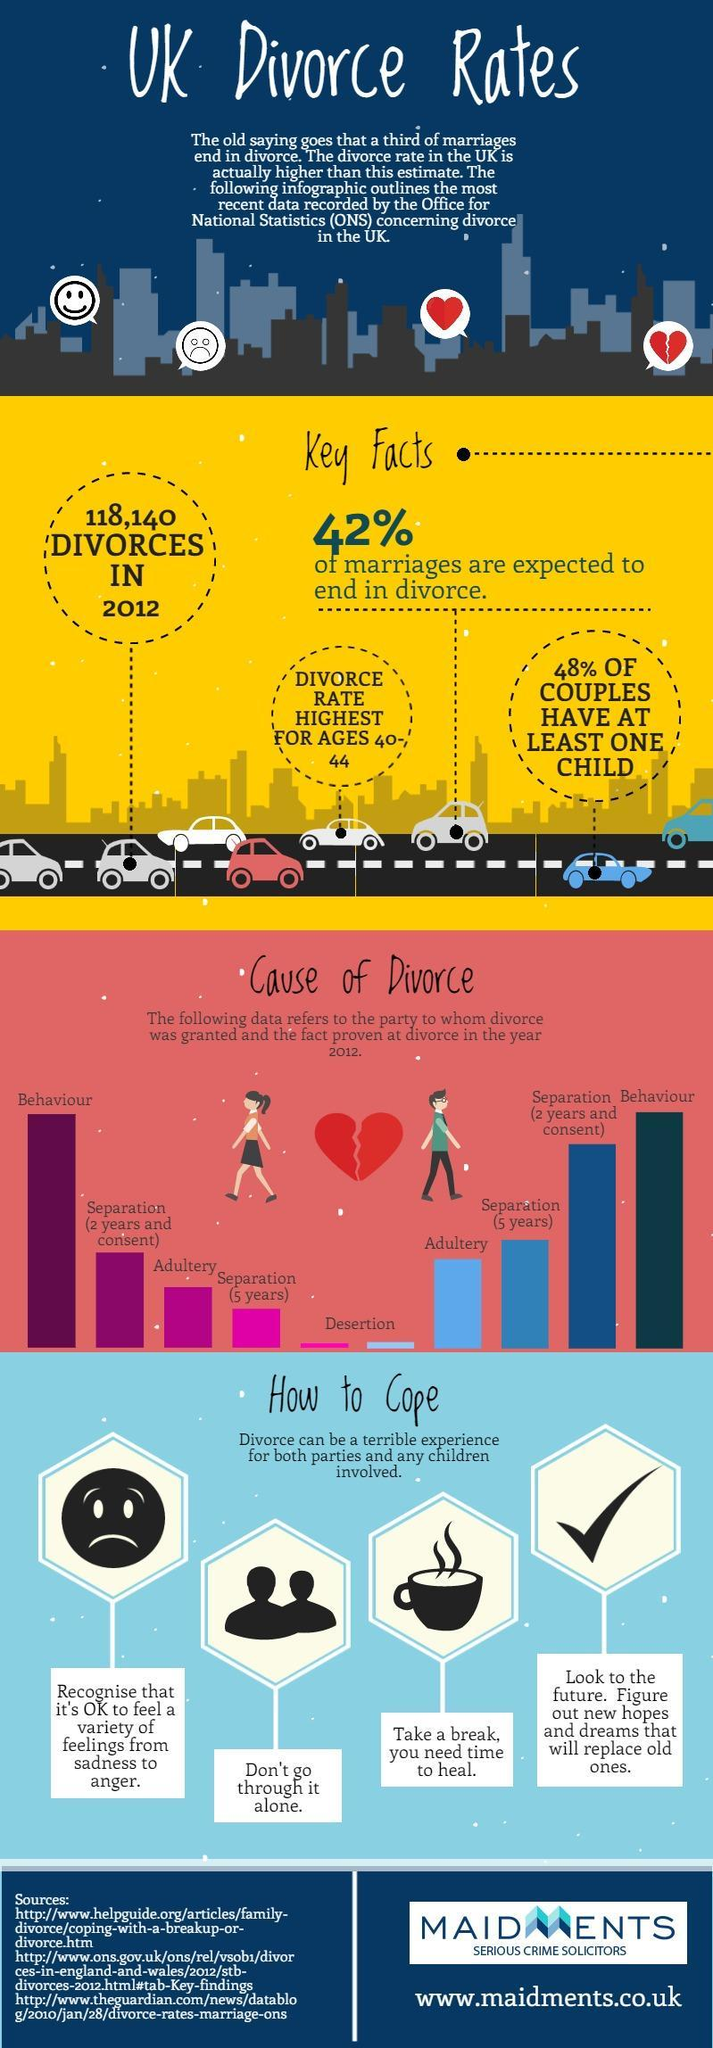What is the second highest reason for men to be granted divorce in the year 2012?
Answer the question with a short phrase. separation(2 years and consent) What is the third highest reason for men to be granted divorce in the year 2012? separation(5 years) which age group has the highest divorce rate? 40-44 What is the third highest reason for women to be granted divorce in the year 2012? Adultery 